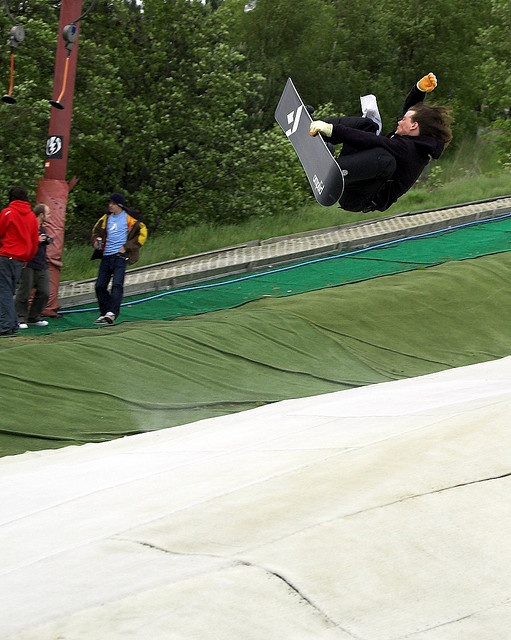Describe the objects in this image and their specific colors. I can see people in black, gray, white, and darkgreen tones, skateboard in black and gray tones, people in black, gray, darkgray, and lightblue tones, people in black, brown, and maroon tones, and snowboard in black and gray tones in this image. 